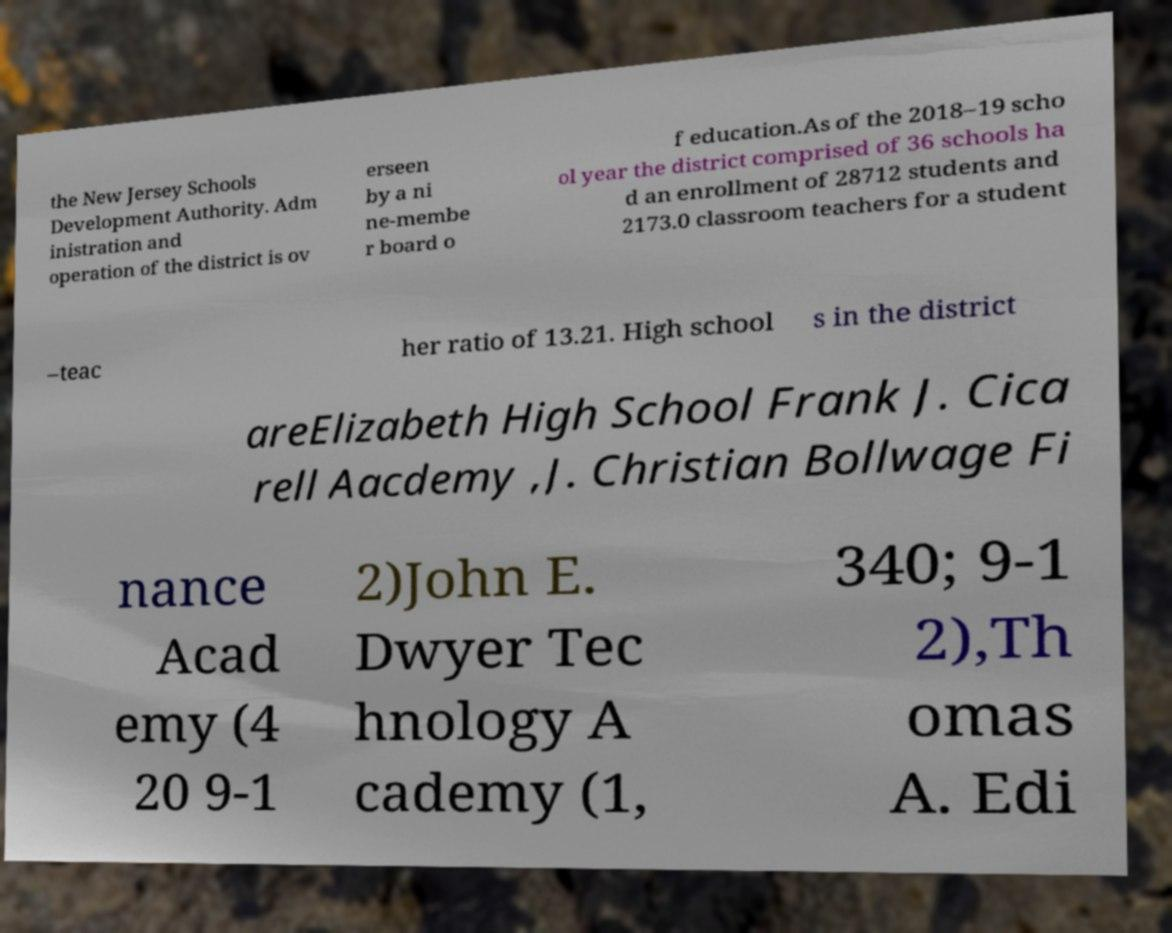Could you assist in decoding the text presented in this image and type it out clearly? the New Jersey Schools Development Authority. Adm inistration and operation of the district is ov erseen by a ni ne-membe r board o f education.As of the 2018–19 scho ol year the district comprised of 36 schools ha d an enrollment of 28712 students and 2173.0 classroom teachers for a student –teac her ratio of 13.21. High school s in the district areElizabeth High School Frank J. Cica rell Aacdemy ,J. Christian Bollwage Fi nance Acad emy (4 20 9-1 2)John E. Dwyer Tec hnology A cademy (1, 340; 9-1 2),Th omas A. Edi 